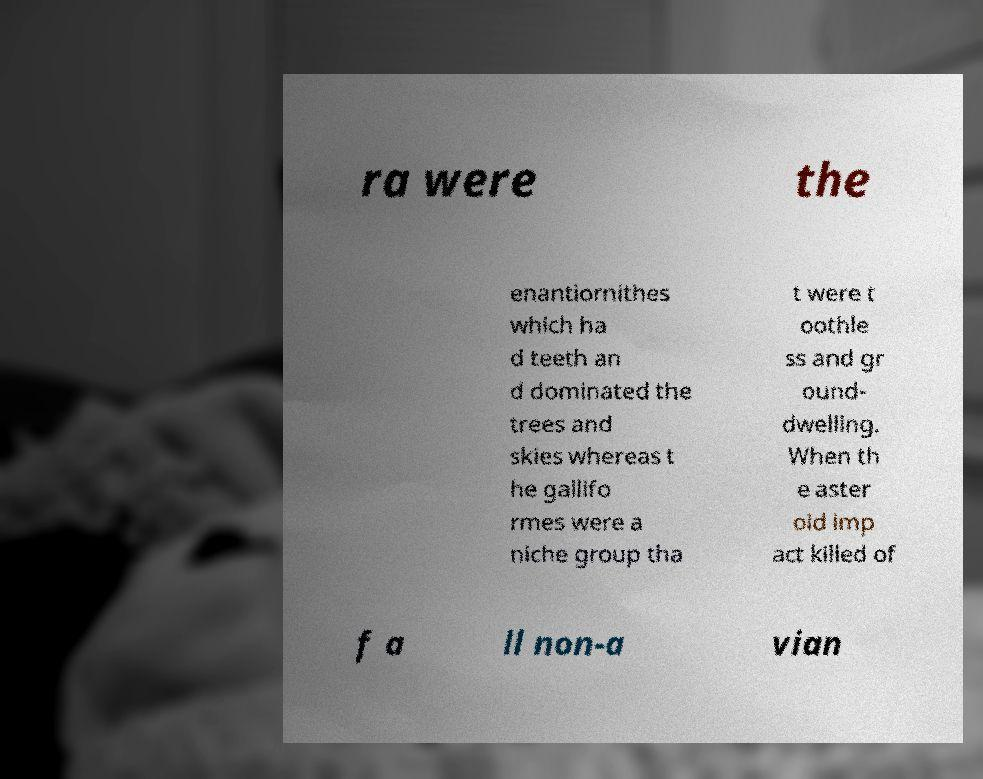For documentation purposes, I need the text within this image transcribed. Could you provide that? ra were the enantiornithes which ha d teeth an d dominated the trees and skies whereas t he gallifo rmes were a niche group tha t were t oothle ss and gr ound- dwelling. When th e aster oid imp act killed of f a ll non-a vian 